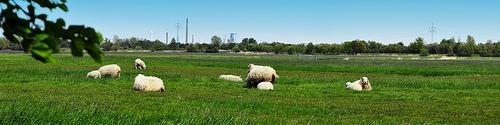Question: where are the sheep?
Choices:
A. On the grass.
B. On the hill.
C. In the zoo.
D. In the barn.
Answer with the letter. Answer: A Question: how many sheep?
Choices:
A. 8.
B. 7.
C. 6.
D. 9.
Answer with the letter. Answer: A Question: what is in the background?
Choices:
A. Mountains.
B. Beach.
C. Trees.
D. Buildings.
Answer with the letter. Answer: C Question: why are they there?
Choices:
A. Walking.
B. Resting.
C. Protesting.
D. Swimming.
Answer with the letter. Answer: B Question: who is watching the lambs?
Choices:
A. The zookeeper.
B. The reporter.
C. The young girl.
D. People.
Answer with the letter. Answer: D 